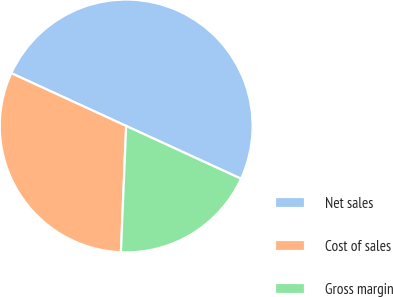Convert chart. <chart><loc_0><loc_0><loc_500><loc_500><pie_chart><fcel>Net sales<fcel>Cost of sales<fcel>Gross margin<nl><fcel>50.0%<fcel>31.19%<fcel>18.81%<nl></chart> 